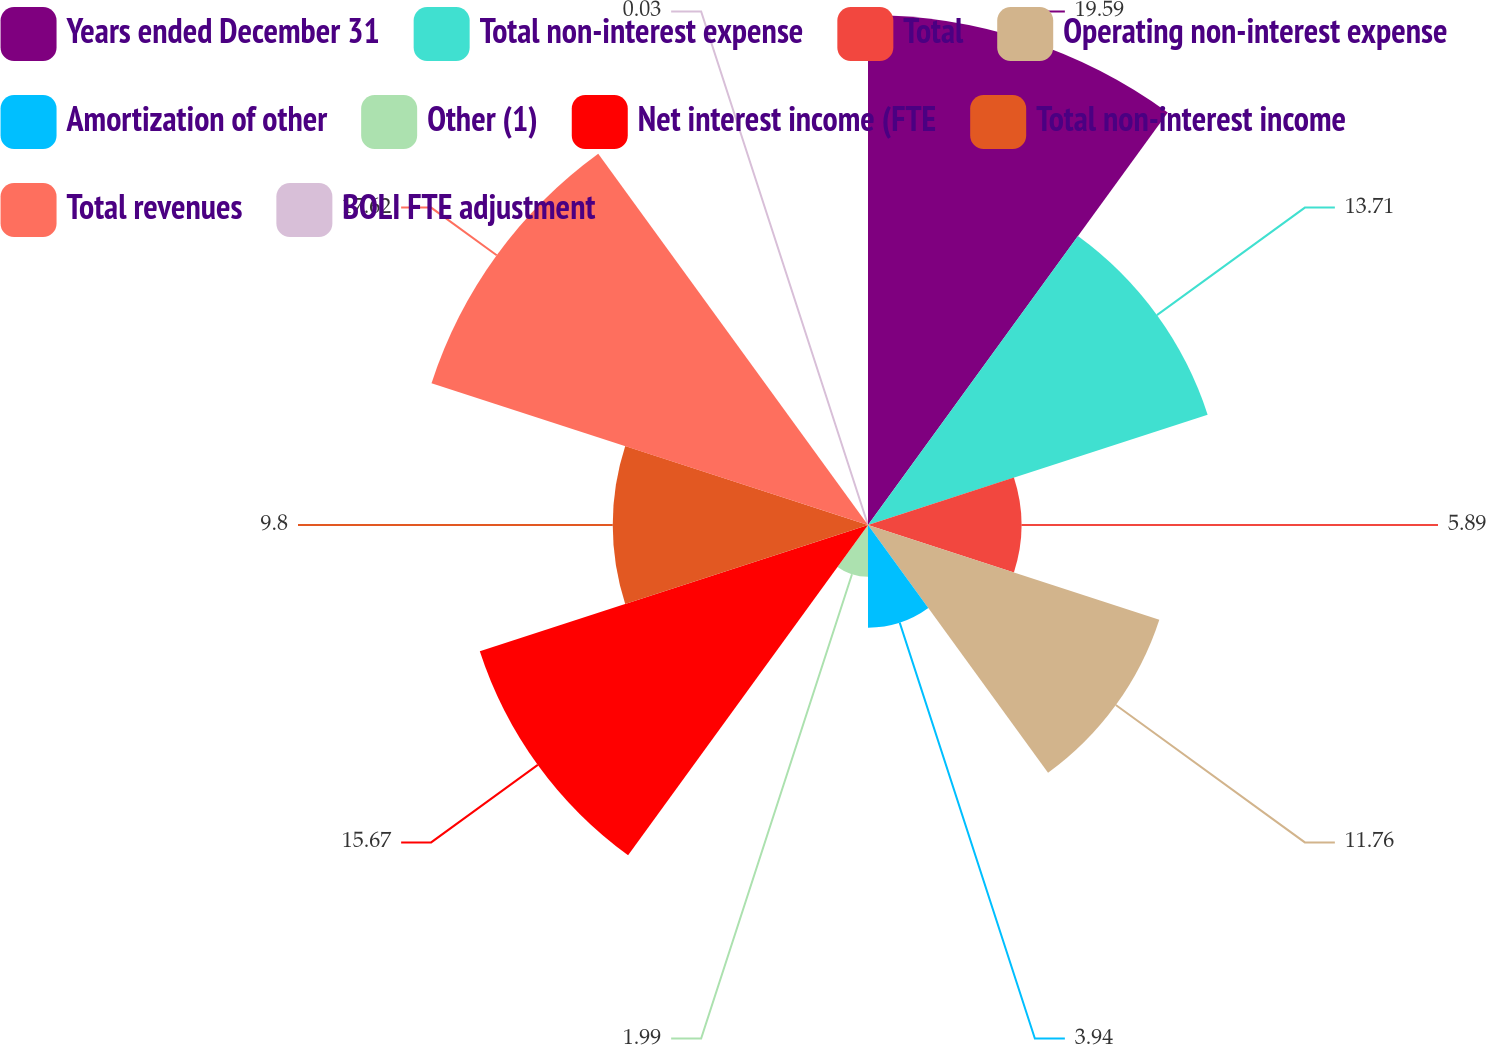Convert chart to OTSL. <chart><loc_0><loc_0><loc_500><loc_500><pie_chart><fcel>Years ended December 31<fcel>Total non-interest expense<fcel>Total<fcel>Operating non-interest expense<fcel>Amortization of other<fcel>Other (1)<fcel>Net interest income (FTE<fcel>Total non-interest income<fcel>Total revenues<fcel>BOLI FTE adjustment<nl><fcel>19.58%<fcel>13.71%<fcel>5.89%<fcel>11.76%<fcel>3.94%<fcel>1.99%<fcel>15.67%<fcel>9.8%<fcel>17.62%<fcel>0.03%<nl></chart> 